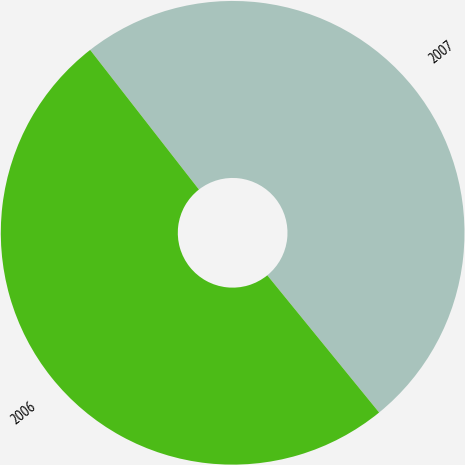Convert chart. <chart><loc_0><loc_0><loc_500><loc_500><pie_chart><fcel>2007<fcel>2006<nl><fcel>49.65%<fcel>50.35%<nl></chart> 